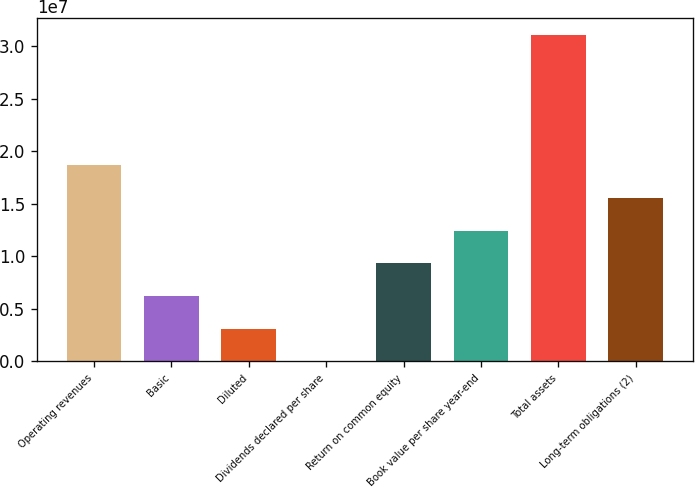Convert chart. <chart><loc_0><loc_0><loc_500><loc_500><bar_chart><fcel>Operating revenues<fcel>Basic<fcel>Diluted<fcel>Dividends declared per share<fcel>Return on common equity<fcel>Book value per share year-end<fcel>Total assets<fcel>Long-term obligations (2)<nl><fcel>1.86496e+07<fcel>6.21655e+06<fcel>3.10828e+06<fcel>2.16<fcel>9.32482e+06<fcel>1.24331e+07<fcel>3.10827e+07<fcel>1.55414e+07<nl></chart> 